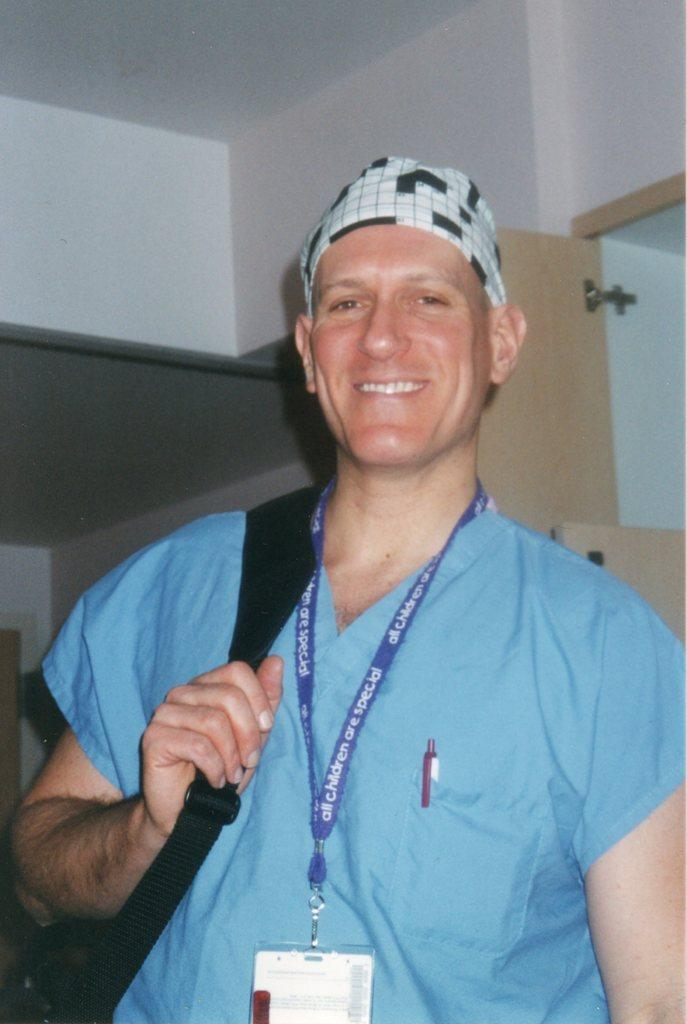Who is present in the image? There is a person in the image. What is the person holding? The person is holding a bag. What is the person's facial expression? The person is smiling. What can be seen in the background of the image? There are walls and a door in the background of the image. How many horses are visible in the image? There are no horses present in the image. What type of jail can be seen in the image? There is no jail present in the image. 